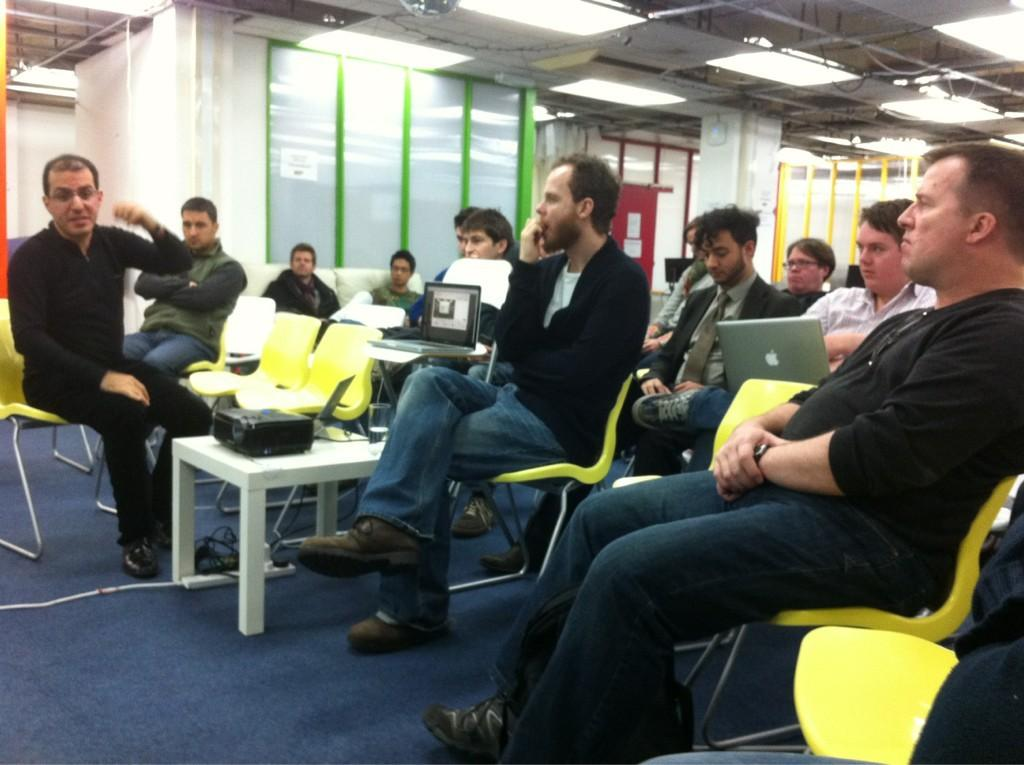What is the color of the wall in the image? The wall in the image is white. What are the people in the image doing? The people in the image are sitting on chairs. What objects are the people holding in the image? Some of the people are holding laptops. What furniture is present in the image? There are tables in the image. What device is placed on one of the tables? There is a projector on one of the tables. Can you see a dog playing a game with the people in the image? There is no dog or game present in the image. Is there a snake slithering on the white wall in the image? There is no snake present in the image; only people, chairs, tables, and a projector are visible. 